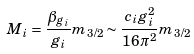<formula> <loc_0><loc_0><loc_500><loc_500>M _ { i } = \frac { \beta _ { g _ { i } } } { g _ { i } } m _ { 3 / 2 } \sim \frac { c _ { i } g ^ { 2 } _ { i } } { 1 6 \pi ^ { 2 } } m _ { 3 / 2 }</formula> 